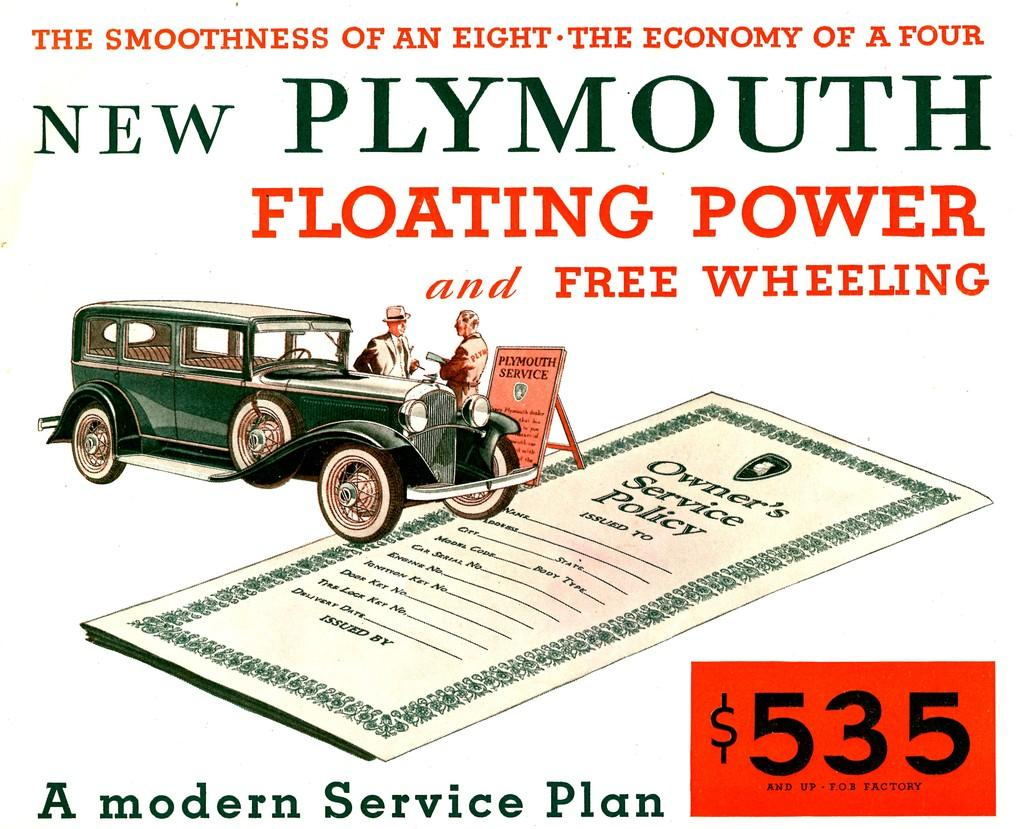What is featured on the poster in the image? The poster contains text and a picture of a car. Can you describe the picture of the car on the poster? The picture of the car on the poster shows two people inside the car. What is the purpose of the cave in the image? There is no cave present in the image; it features a poster with a picture of a car. Who is the owner of the car in the image? The image does not provide information about the ownership of the car; it only shows a picture of a car with two people inside. 